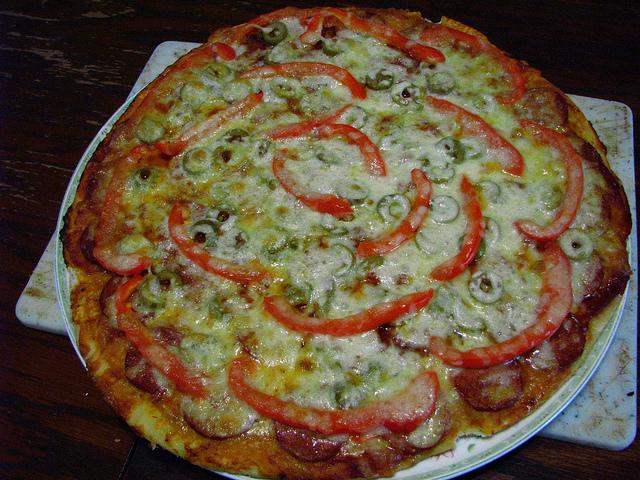What toppings are on the pizza?
Concise answer only. Olives. How many different kinds of pizza are integrated into this one pizza?
Quick response, please. 1. What toppings are on this pizza?
Keep it brief. Tomato. In this pizza homemade?
Quick response, please. Yes. What food is this?
Write a very short answer. Pizza. 